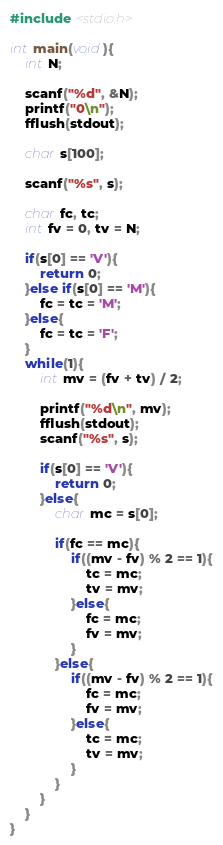Convert code to text. <code><loc_0><loc_0><loc_500><loc_500><_C_>#include <stdio.h>

int main(void){
    int N;

    scanf("%d", &N);
    printf("0\n");
    fflush(stdout);

    char s[100];

    scanf("%s", s);
    
    char fc, tc;
    int fv = 0, tv = N;

    if(s[0] == 'V'){
        return 0;
    }else if(s[0] == 'M'){
        fc = tc = 'M';
    }else{
        fc = tc = 'F';
    }
    while(1){
        int mv = (fv + tv) / 2;

        printf("%d\n", mv);
        fflush(stdout);
        scanf("%s", s);

        if(s[0] == 'V'){
            return 0;
        }else{
            char mc = s[0];

            if(fc == mc){
                if((mv - fv) % 2 == 1){
                    tc = mc;
                    tv = mv;
                }else{
                    fc = mc;
                    fv = mv;
                }
            }else{
                if((mv - fv) % 2 == 1){
                    fc = mc;
                    fv = mv;
                }else{
                    tc = mc;
                    tv = mv;
                }
            }
        }
    }
}</code> 